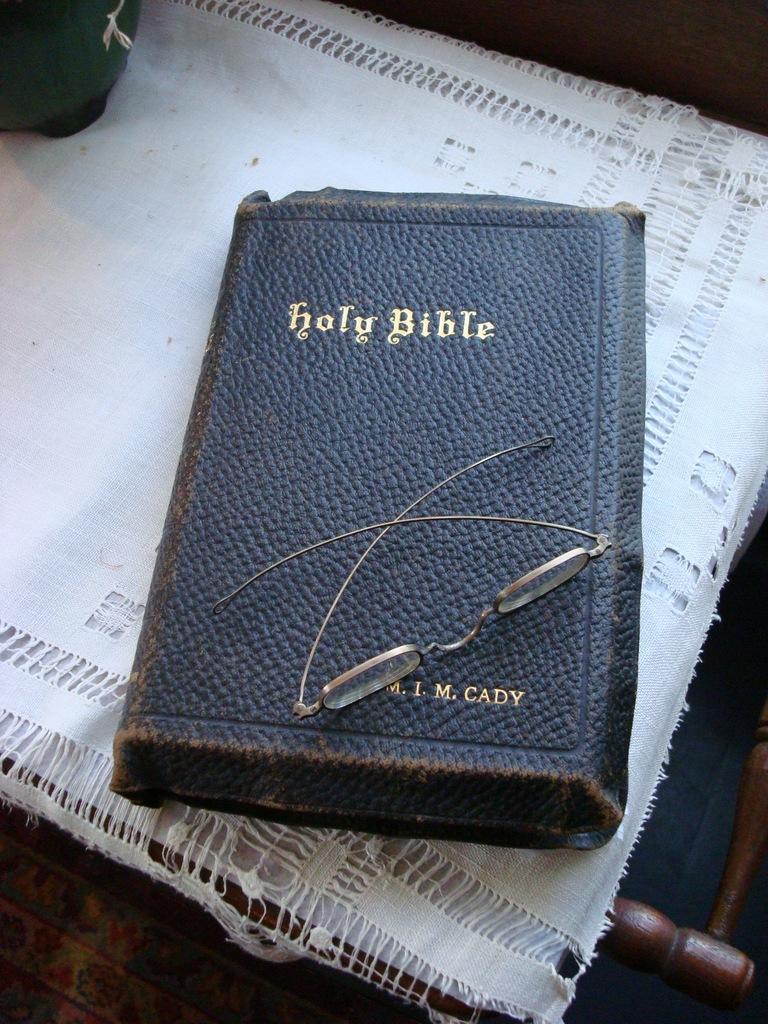Describe this image in one or two sentences. In the foreground of the picture there are bible, on the bible there are spectacles. They are placed on a wooden object. At the top left there is an object. 